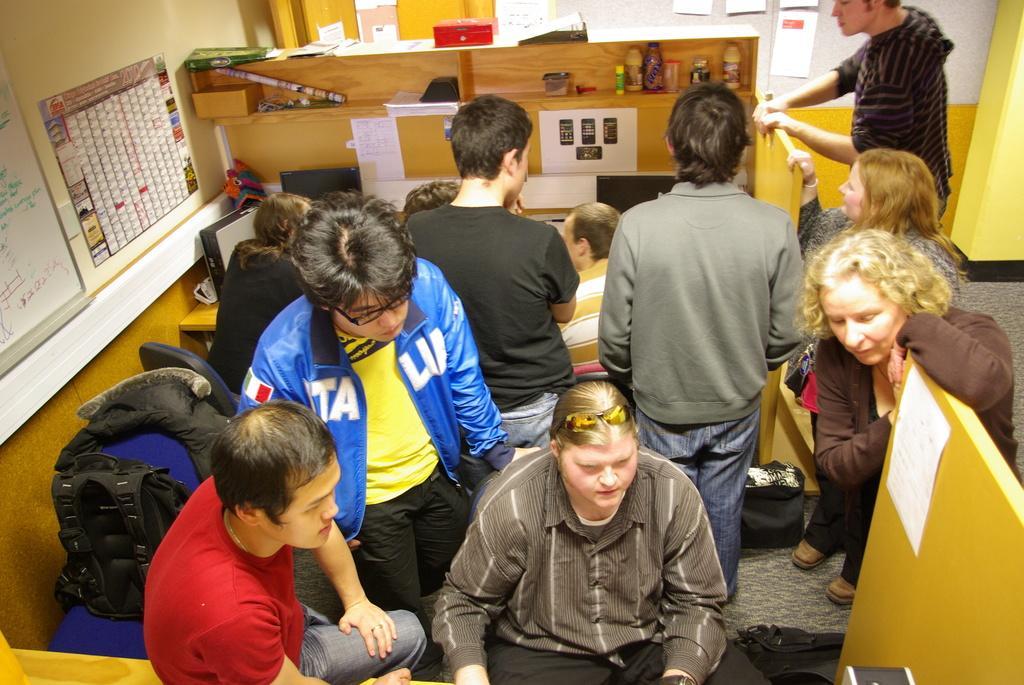Can you describe this image briefly? In this image there are group of persons standing and sitting and there are posters on the wall and there is a table, on a table there are monitors and there are objects in the shelf. 